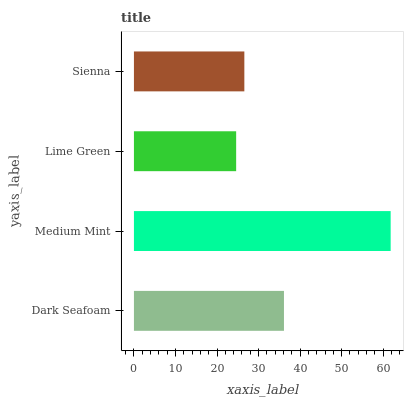Is Lime Green the minimum?
Answer yes or no. Yes. Is Medium Mint the maximum?
Answer yes or no. Yes. Is Medium Mint the minimum?
Answer yes or no. No. Is Lime Green the maximum?
Answer yes or no. No. Is Medium Mint greater than Lime Green?
Answer yes or no. Yes. Is Lime Green less than Medium Mint?
Answer yes or no. Yes. Is Lime Green greater than Medium Mint?
Answer yes or no. No. Is Medium Mint less than Lime Green?
Answer yes or no. No. Is Dark Seafoam the high median?
Answer yes or no. Yes. Is Sienna the low median?
Answer yes or no. Yes. Is Medium Mint the high median?
Answer yes or no. No. Is Medium Mint the low median?
Answer yes or no. No. 